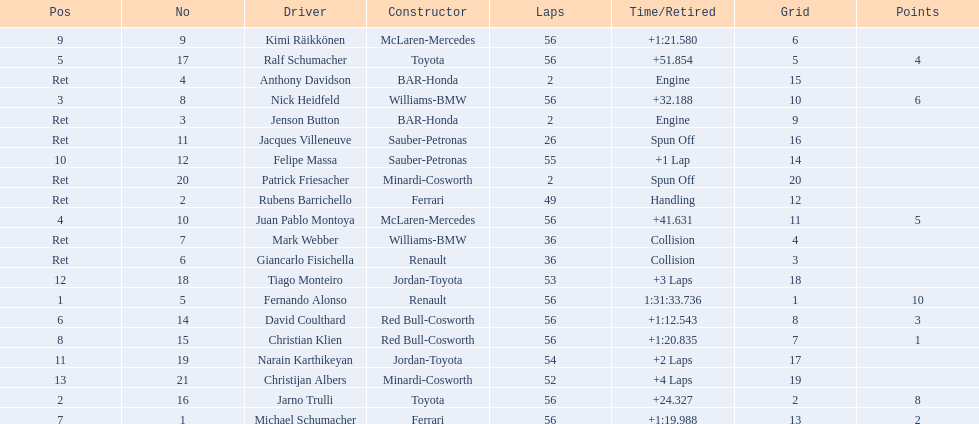What place did fernando alonso finish? 1. How long did it take alonso to finish the race? 1:31:33.736. 